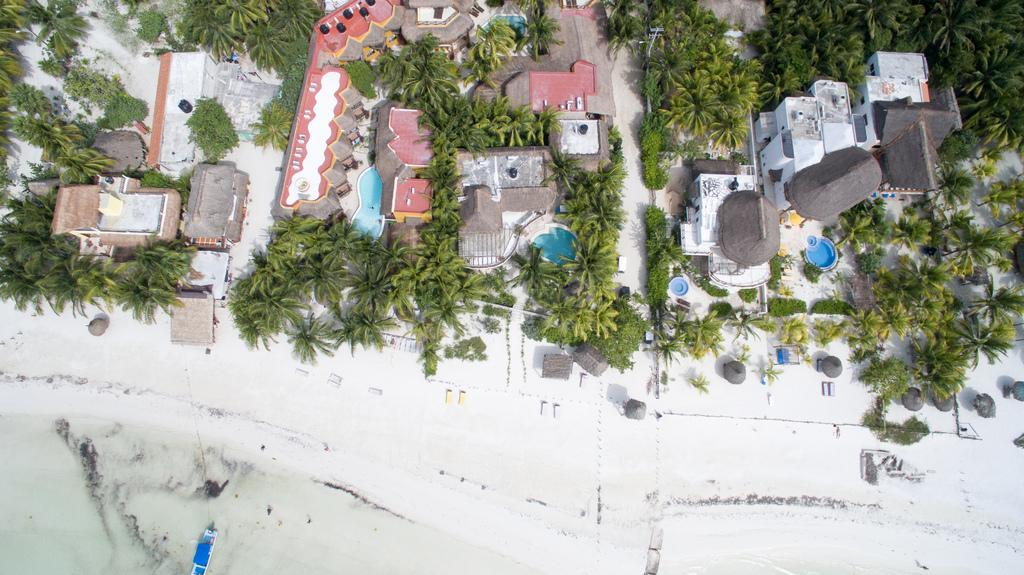What type of view is shown in the image? The image is captured from an aerial view. What structures can be seen from this perspective? There are many buildings visible in the image. Are there any recreational areas in the image? Yes, swimming pools are present in the image. What type of natural elements can be seen in the image? Trees and sand are visible in the image. What specific location can be identified in the image? A beach is visible in the image. What type of rod is used to catch fish at the beach in the image? There is no rod or fishing activity visible in the image; it only shows a beach with sand and trees. 